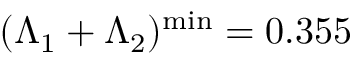Convert formula to latex. <formula><loc_0><loc_0><loc_500><loc_500>( \Lambda _ { 1 } + \Lambda _ { 2 } ) ^ { \min } = 0 . 3 5 5</formula> 